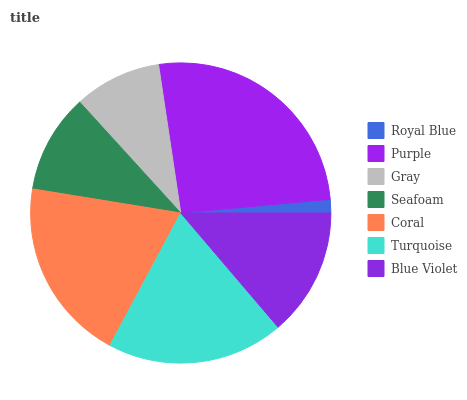Is Royal Blue the minimum?
Answer yes or no. Yes. Is Purple the maximum?
Answer yes or no. Yes. Is Gray the minimum?
Answer yes or no. No. Is Gray the maximum?
Answer yes or no. No. Is Purple greater than Gray?
Answer yes or no. Yes. Is Gray less than Purple?
Answer yes or no. Yes. Is Gray greater than Purple?
Answer yes or no. No. Is Purple less than Gray?
Answer yes or no. No. Is Blue Violet the high median?
Answer yes or no. Yes. Is Blue Violet the low median?
Answer yes or no. Yes. Is Seafoam the high median?
Answer yes or no. No. Is Coral the low median?
Answer yes or no. No. 